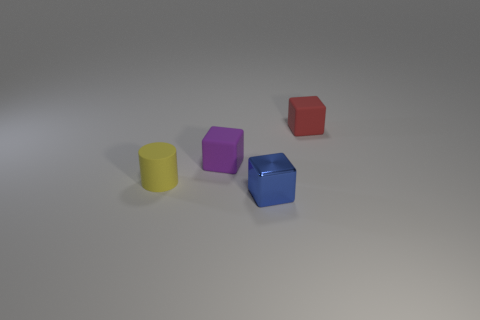Can you tell me the colors and shapes of the objects presented in this image? Certainly! There are five objects in this image, each with a distinct color and shape. Starting from the left, there is a yellow cylinder, a purple cube, a red cube, a blue hexagonal prism, and in the background, a slightly hidden green sphere. 